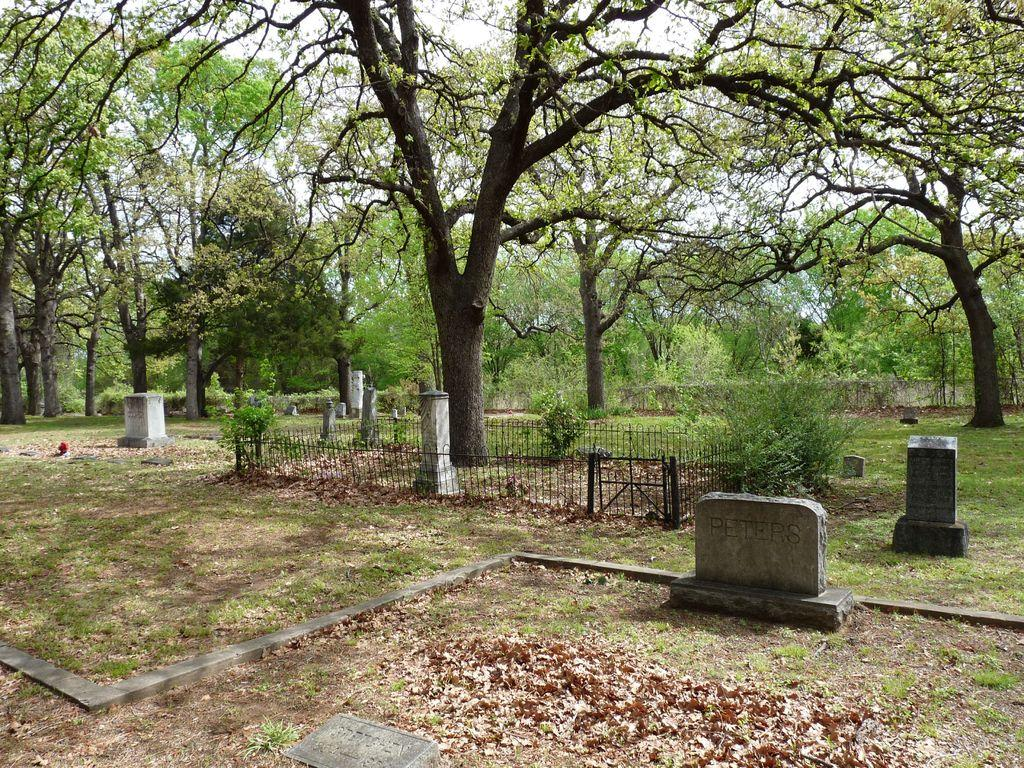What can be seen in the image that represents burial sites? There are graves in the image. What type of vegetation is present on the ground in the image? Dry leaves, plants, and grass are visible in the image. What type of barrier is present in the image? There is a fence in the image. What type of natural environment is visible in the image? Trees and grass are visible in the image. What is visible in the background of the image? The sky and trees are visible in the background of the image. What type of oil is being used to create steam in the image? There is no oil or steam present in the image; it features graves, dry leaves, a fence, plants, trees, grass, and sky. 